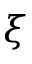<formula> <loc_0><loc_0><loc_500><loc_500>\xi</formula> 